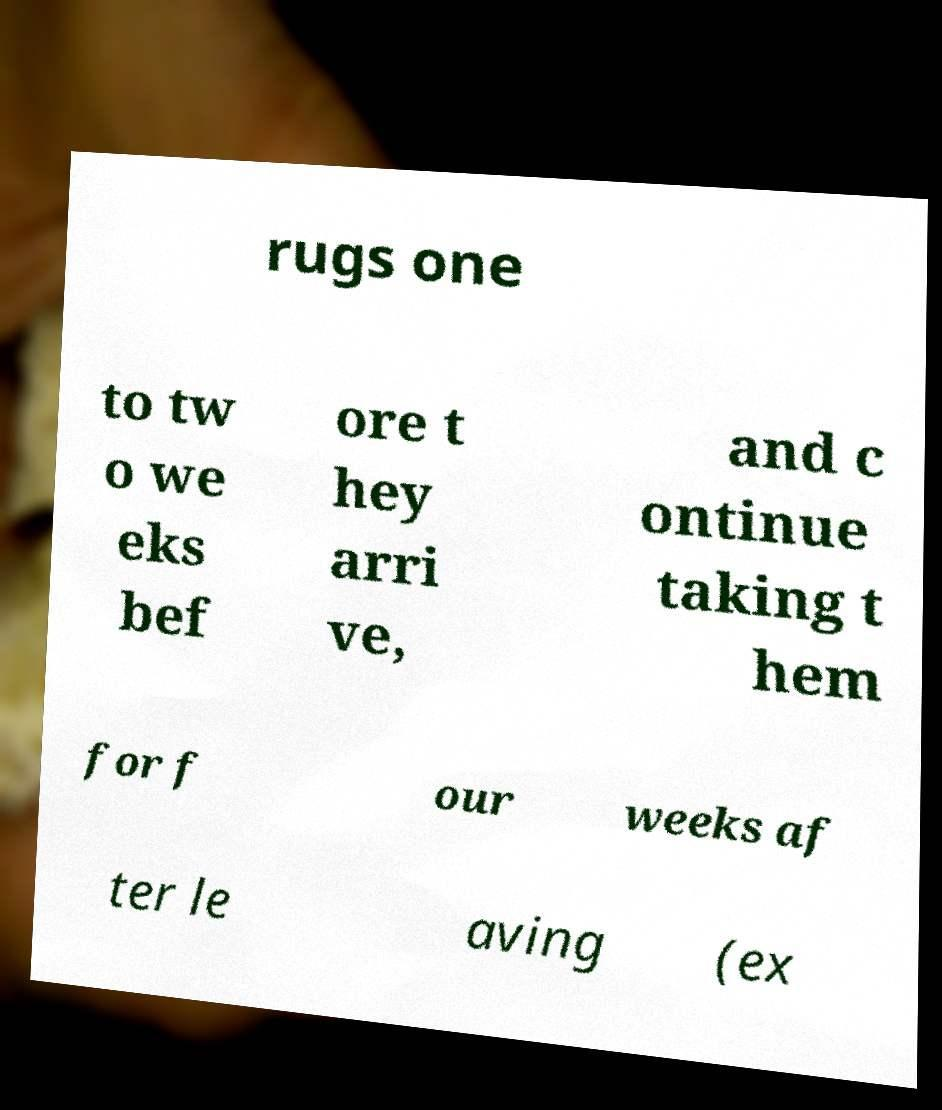For documentation purposes, I need the text within this image transcribed. Could you provide that? rugs one to tw o we eks bef ore t hey arri ve, and c ontinue taking t hem for f our weeks af ter le aving (ex 